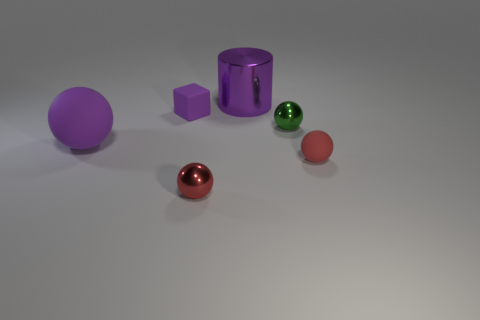What material is the big object that is the same shape as the tiny green metallic object?
Provide a succinct answer. Rubber. What number of objects are big red blocks or metallic objects?
Offer a very short reply. 3. The big thing that is to the right of the red thing to the left of the large object that is on the right side of the tiny cube is made of what material?
Offer a terse response. Metal. What material is the object to the left of the small purple cube?
Ensure brevity in your answer.  Rubber. Are there any matte spheres of the same size as the purple metallic cylinder?
Offer a terse response. Yes. There is a tiny matte object that is to the left of the large purple metal thing; is it the same color as the big matte thing?
Offer a terse response. Yes. What number of red things are either blocks or small balls?
Your answer should be compact. 2. How many cylinders are the same color as the matte block?
Keep it short and to the point. 1. Does the purple block have the same material as the purple ball?
Make the answer very short. Yes. There is a small sphere to the left of the big cylinder; how many large purple spheres are to the right of it?
Your response must be concise. 0. 